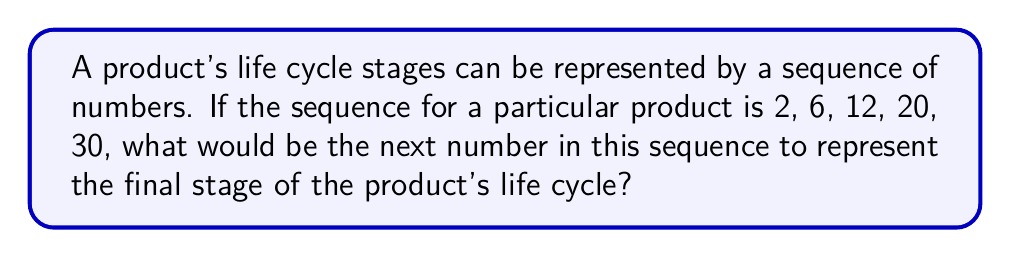Help me with this question. To solve this problem, we need to identify the pattern in the given sequence. Let's analyze the differences between consecutive terms:

1. From 2 to 6: Difference is 4
2. From 6 to 12: Difference is 6
3. From 12 to 20: Difference is 8
4. From 20 to 30: Difference is 10

We can observe that the differences are increasing by 2 each time. This suggests an arithmetic sequence of second order.

Let's define the sequence of differences:
$d_n = 2 + 2(n-1)$, where $n$ is the position of the difference.

Now, to find the next term in the original sequence, we need to add the next difference to the last given term:

1. Calculate the next difference:
   $d_5 = 2 + 2(5-1) = 2 + 8 = 10$

2. Add this difference to the last term:
   $30 + 10 = 40$

Therefore, the next number in the sequence representing the final stage of the product's life cycle would be 40.
Answer: 40 